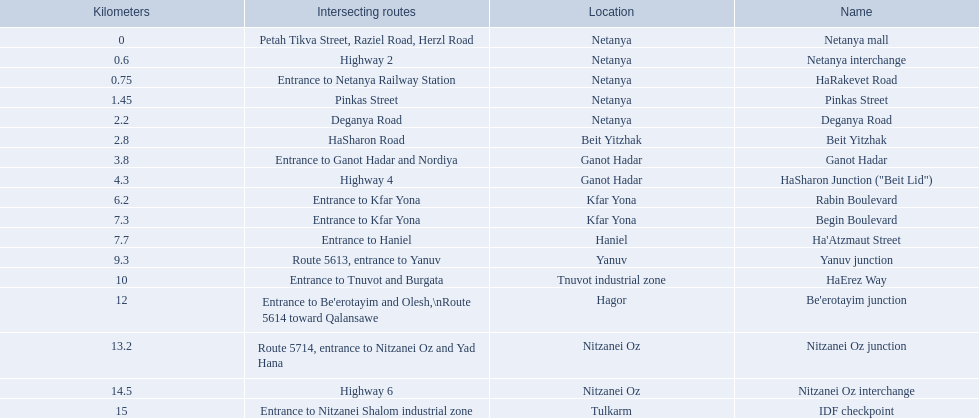What are all the names? Netanya mall, Netanya interchange, HaRakevet Road, Pinkas Street, Deganya Road, Beit Yitzhak, Ganot Hadar, HaSharon Junction ("Beit Lid"), Rabin Boulevard, Begin Boulevard, Ha'Atzmaut Street, Yanuv junction, HaErez Way, Be'erotayim junction, Nitzanei Oz junction, Nitzanei Oz interchange, IDF checkpoint. Where do they intersect? Petah Tikva Street, Raziel Road, Herzl Road, Highway 2, Entrance to Netanya Railway Station, Pinkas Street, Deganya Road, HaSharon Road, Entrance to Ganot Hadar and Nordiya, Highway 4, Entrance to Kfar Yona, Entrance to Kfar Yona, Entrance to Haniel, Route 5613, entrance to Yanuv, Entrance to Tnuvot and Burgata, Entrance to Be'erotayim and Olesh,\nRoute 5614 toward Qalansawe, Route 5714, entrance to Nitzanei Oz and Yad Hana, Highway 6, Entrance to Nitzanei Shalom industrial zone. And which shares an intersection with rabin boulevard? Begin Boulevard. 